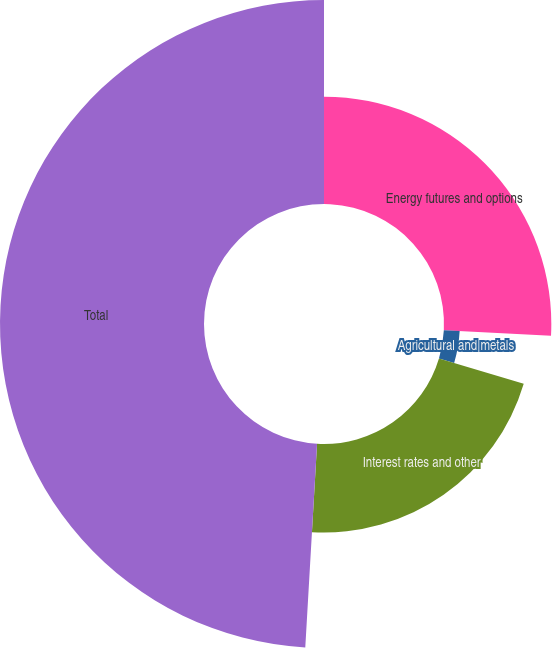<chart> <loc_0><loc_0><loc_500><loc_500><pie_chart><fcel>Energy futures and options<fcel>Agricultural and metals<fcel>Interest rates and other<fcel>Total<nl><fcel>25.82%<fcel>3.81%<fcel>21.29%<fcel>49.08%<nl></chart> 